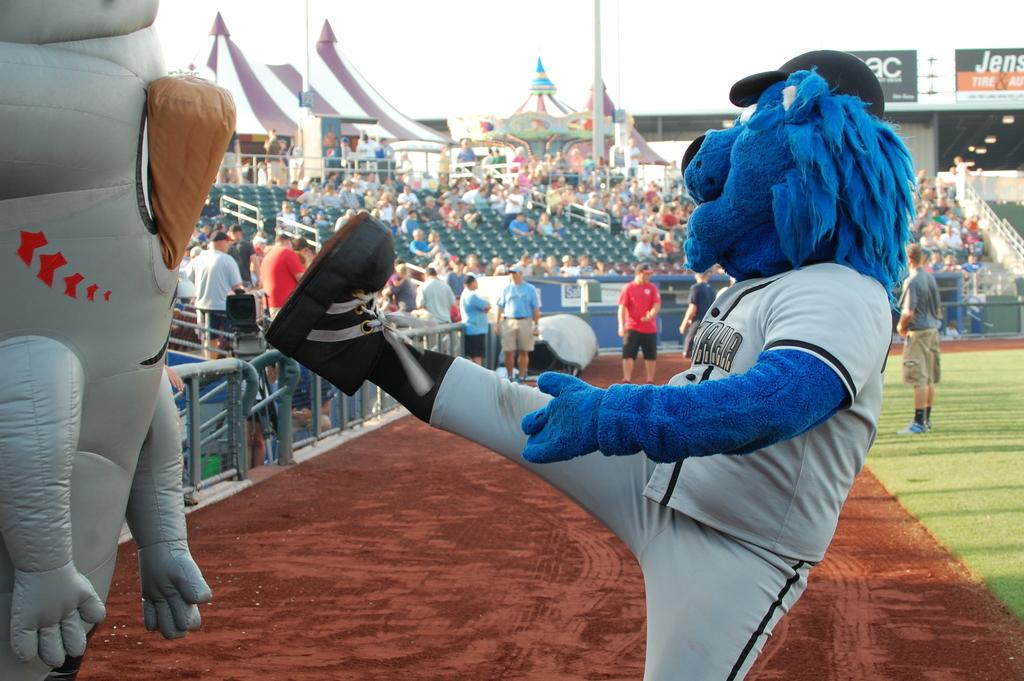<image>
Present a compact description of the photo's key features. A sports mascot kicks out at a blow up figure, with a sign in the background with the partial word Jens and Tire legible. 